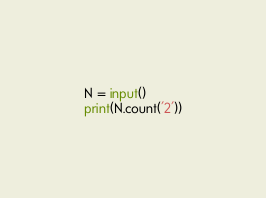Convert code to text. <code><loc_0><loc_0><loc_500><loc_500><_Python_>N = input()
print(N.count('2'))</code> 